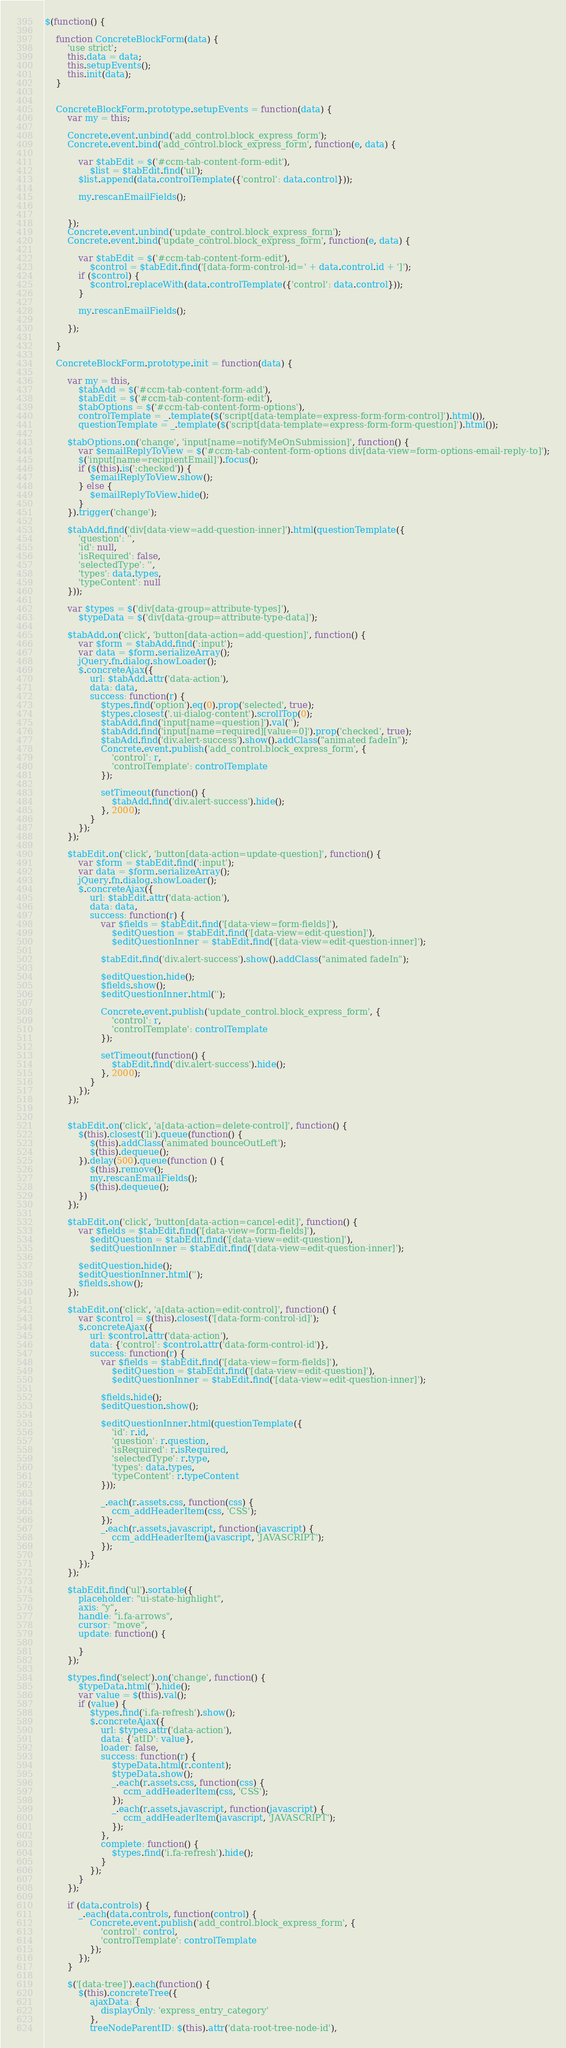Convert code to text. <code><loc_0><loc_0><loc_500><loc_500><_JavaScript_>$(function() {

    function ConcreteBlockForm(data) {
        'use strict';
        this.data = data;
        this.setupEvents();
        this.init(data);
    }


    ConcreteBlockForm.prototype.setupEvents = function(data) {
        var my = this;

        Concrete.event.unbind('add_control.block_express_form');
        Concrete.event.bind('add_control.block_express_form', function(e, data) {

            var $tabEdit = $('#ccm-tab-content-form-edit'),
                $list = $tabEdit.find('ul');
            $list.append(data.controlTemplate({'control': data.control}));

            my.rescanEmailFields();


        });
        Concrete.event.unbind('update_control.block_express_form');
        Concrete.event.bind('update_control.block_express_form', function(e, data) {

            var $tabEdit = $('#ccm-tab-content-form-edit'),
                $control = $tabEdit.find('[data-form-control-id=' + data.control.id + ']');
            if ($control) {
                $control.replaceWith(data.controlTemplate({'control': data.control}));
            }

            my.rescanEmailFields();

        });

    }

    ConcreteBlockForm.prototype.init = function(data) {

        var my = this,
            $tabAdd = $('#ccm-tab-content-form-add'),
            $tabEdit = $('#ccm-tab-content-form-edit'),
            $tabOptions = $('#ccm-tab-content-form-options'),
            controlTemplate = _.template($('script[data-template=express-form-form-control]').html()),
            questionTemplate = _.template($('script[data-template=express-form-form-question]').html());

        $tabOptions.on('change', 'input[name=notifyMeOnSubmission]', function() {
            var $emailReplyToView = $('#ccm-tab-content-form-options div[data-view=form-options-email-reply-to]');
            $('input[name=recipientEmail]').focus();
            if ($(this).is(':checked')) {
                $emailReplyToView.show();
            } else {
                $emailReplyToView.hide();
            }
        }).trigger('change');

        $tabAdd.find('div[data-view=add-question-inner]').html(questionTemplate({
            'question': '',
            'id': null,
            'isRequired': false,
            'selectedType': '',
            'types': data.types,
            'typeContent': null
        }));

        var $types = $('div[data-group=attribute-types]'),
            $typeData = $('div[data-group=attribute-type-data]');

        $tabAdd.on('click', 'button[data-action=add-question]', function() {
            var $form = $tabAdd.find(':input');
            var data = $form.serializeArray();
            jQuery.fn.dialog.showLoader();
            $.concreteAjax({
                url: $tabAdd.attr('data-action'),
                data: data,
                success: function(r) {
                    $types.find('option').eq(0).prop('selected', true);
                    $types.closest('.ui-dialog-content').scrollTop(0);
                    $tabAdd.find('input[name=question]').val('');
                    $tabAdd.find('input[name=required][value=0]').prop('checked', true);
                    $tabAdd.find('div.alert-success').show().addClass("animated fadeIn");
                    Concrete.event.publish('add_control.block_express_form', {
                        'control': r,
                        'controlTemplate': controlTemplate
                    });

                    setTimeout(function() {
                        $tabAdd.find('div.alert-success').hide();
                    }, 2000);
                }
            });
        });

        $tabEdit.on('click', 'button[data-action=update-question]', function() {
            var $form = $tabEdit.find(':input');
            var data = $form.serializeArray();
            jQuery.fn.dialog.showLoader();
            $.concreteAjax({
                url: $tabEdit.attr('data-action'),
                data: data,
                success: function(r) {
                    var $fields = $tabEdit.find('[data-view=form-fields]'),
                        $editQuestion = $tabEdit.find('[data-view=edit-question]'),
                        $editQuestionInner = $tabEdit.find('[data-view=edit-question-inner]');

                    $tabEdit.find('div.alert-success').show().addClass("animated fadeIn");

                    $editQuestion.hide();
                    $fields.show();
                    $editQuestionInner.html('');

                    Concrete.event.publish('update_control.block_express_form', {
                        'control': r,
                        'controlTemplate': controlTemplate
                    });

                    setTimeout(function() {
                        $tabEdit.find('div.alert-success').hide();
                    }, 2000);
                }
            });
        });


        $tabEdit.on('click', 'a[data-action=delete-control]', function() {
            $(this).closest('li').queue(function() {
                $(this).addClass('animated bounceOutLeft');
                $(this).dequeue();
            }).delay(500).queue(function () {
                $(this).remove();
                my.rescanEmailFields();
                $(this).dequeue();
            })
        });

        $tabEdit.on('click', 'button[data-action=cancel-edit]', function() {
            var $fields = $tabEdit.find('[data-view=form-fields]'),
                $editQuestion = $tabEdit.find('[data-view=edit-question]'),
                $editQuestionInner = $tabEdit.find('[data-view=edit-question-inner]');

            $editQuestion.hide();
            $editQuestionInner.html('');
            $fields.show();
        });

        $tabEdit.on('click', 'a[data-action=edit-control]', function() {
            var $control = $(this).closest('[data-form-control-id]');
            $.concreteAjax({
                url: $control.attr('data-action'),
                data: {'control': $control.attr('data-form-control-id')},
                success: function(r) {
                    var $fields = $tabEdit.find('[data-view=form-fields]'),
                        $editQuestion = $tabEdit.find('[data-view=edit-question]'),
                        $editQuestionInner = $tabEdit.find('[data-view=edit-question-inner]');

                    $fields.hide();
                    $editQuestion.show();

                    $editQuestionInner.html(questionTemplate({
                        'id': r.id,
                        'question': r.question,
                        'isRequired': r.isRequired,
                        'selectedType': r.type,
                        'types': data.types,
                        'typeContent': r.typeContent
                    }));

                    _.each(r.assets.css, function(css) {
                        ccm_addHeaderItem(css, 'CSS');
                    });
                    _.each(r.assets.javascript, function(javascript) {
                        ccm_addHeaderItem(javascript, 'JAVASCRIPT');
                    });
                }
            });
        });

        $tabEdit.find('ul').sortable({
            placeholder: "ui-state-highlight",
            axis: "y",
            handle: "i.fa-arrows",
            cursor: "move",
            update: function() {

            }
        });

        $types.find('select').on('change', function() {
            $typeData.html('').hide();
            var value = $(this).val();
            if (value) {
                $types.find('i.fa-refresh').show();
                $.concreteAjax({
                    url: $types.attr('data-action'),
                    data: {'atID': value},
                    loader: false,
                    success: function(r) {
                        $typeData.html(r.content);
                        $typeData.show();
                        _.each(r.assets.css, function(css) {
                            ccm_addHeaderItem(css, 'CSS');
                        });
                        _.each(r.assets.javascript, function(javascript) {
                            ccm_addHeaderItem(javascript, 'JAVASCRIPT');
                        });
                    },
                    complete: function() {
                        $types.find('i.fa-refresh').hide();
                    }
                });
            }
        });

        if (data.controls) {
            _.each(data.controls, function(control) {
                Concrete.event.publish('add_control.block_express_form', {
                    'control': control,
                    'controlTemplate': controlTemplate
                });
            });
        }

        $('[data-tree]').each(function() {
            $(this).concreteTree({
                ajaxData: {
                    displayOnly: 'express_entry_category'
                },
                treeNodeParentID: $(this).attr('data-root-tree-node-id'),</code> 